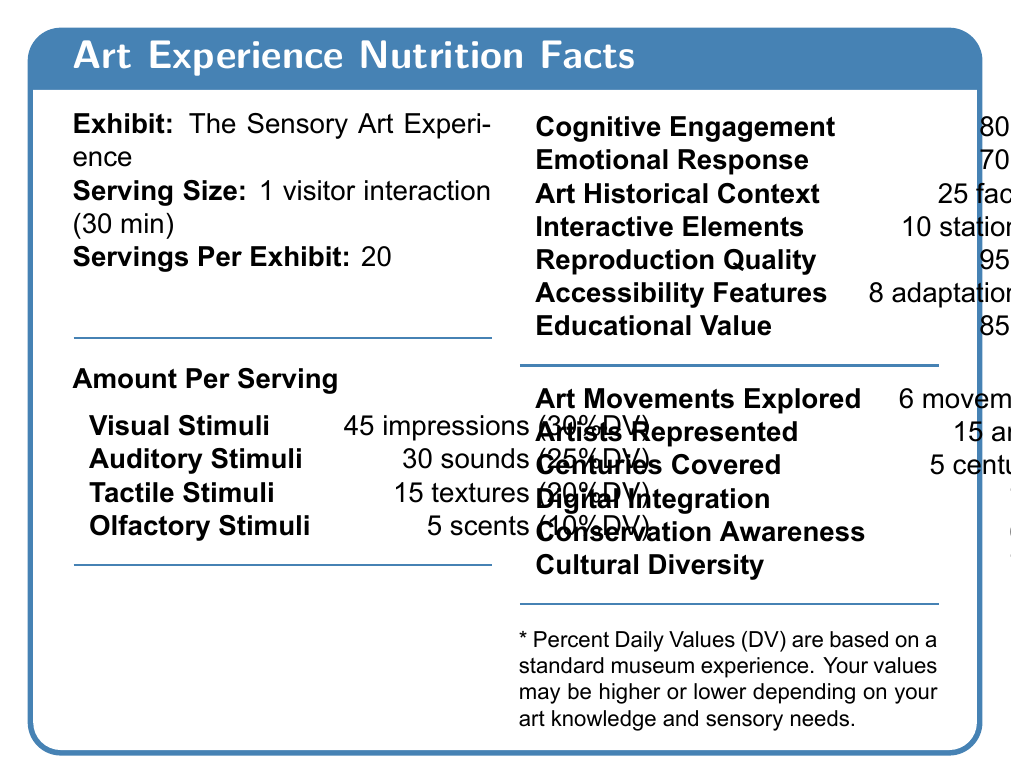what is the exhibit name? The document states the exhibit name as "The Sensory Art Experience".
Answer: The Sensory Art Experience what is the serving size of the exhibit? The document specifies the serving size as "1 visitor interaction (30 minutes)".
Answer: 1 visitor interaction (30 minutes) how many servings per exhibit are there? The document mentions there are 20 servings per exhibit.
Answer: 20 how many visual stimuli impressions are there per serving? The document states there are 45 impressions of visual stimuli per serving.
Answer: 45 impressions what is the amount per serving for auditory stimuli? The document lists 30 sounds as the amount per serving for auditory stimuli.
Answer: 30 sounds what percentage is the cognitive engagement amount per serving? The cognitive engagement amount per serving is indicated as 80%.
Answer: 80% how many facts of art historical context are there per serving? The document mentions there are 25 facts of art historical context per serving.
Answer: 25 facts what is the percent value for emotional response per serving? The document notes that the emotional response is 70% per serving.
Answer: 70% how many artists are represented in the exhibit? The document notes that there are 15 artists represented in the exhibit.
Answer: 15 artists what is the daily value (DV) percentage for reproduction quality? A. 30% B. 40% C. 50% D. 60% The document lists the daily value (DV) percentage for reproduction quality as 50%.
Answer: C how many tactile stimuli are provided per serving? A. 10 B. 15 C. 20 D. 25 The document presents that there are 15 textures of tactile stimuli per serving.
Answer: B does the exhibit cover more or fewer than 4 centuries? The document notes that 5 centuries are covered, which is more than 4 centuries.
Answer: More does the exhibit include any conservation awareness elements? The document includes conservation awareness with an amount of 60% per serving.
Answer: Yes what is the summary of the document? The document provides a thorough overview of an art exhibit in a format similar to a nutrition label. It includes details about sensory experiences (visual, auditory, tactile, olfactory), cognitive and emotional engagement, art historical context, educational value, and more. Each element is quantified to help visitors understand what to expect from the exhibit.
Answer: The document outlines a Nutrition Facts Label for "The Sensory Art Experience" exhibit. It details various sensory stimuli, cognitive and emotional engagement levels, elements of art historical context, and more. The exhibit offers a complete sensory and educational experience quantified in terms of daily values and amounts. how many art movements are explored? The document specifies that 6 art movements are explored.
Answer: 6 how many accessibility adaptations are included? The document lists the number of accessibility adaptations as 8.
Answer: 8 which feature has the highest daily value percentage? The document lists Accessibility Features at 60%, which is the highest daily value percentage among all the listed features.
Answer: Accessibility Features what is the total duration a visitor can interact with the exhibit? The total duration cannot be determined from the document as it only mentions the serving size of 1 visitor interaction (30 minutes) and the number of servings per exhibit (20) without specifying whether visitors can participate in multiple servings.
Answer: Cannot be determined what is the daily value percentage for interactive elements? The daily value percentage for interactive elements is 45%.
Answer: 45% how much digital integration is included per serving? The document mentions a digital integration amount per serving of 70%.
Answer: 70% what percentage is dedicated to educational value in the exhibit? The educational value in the exhibit is specified as 85%.
Answer: 85% 